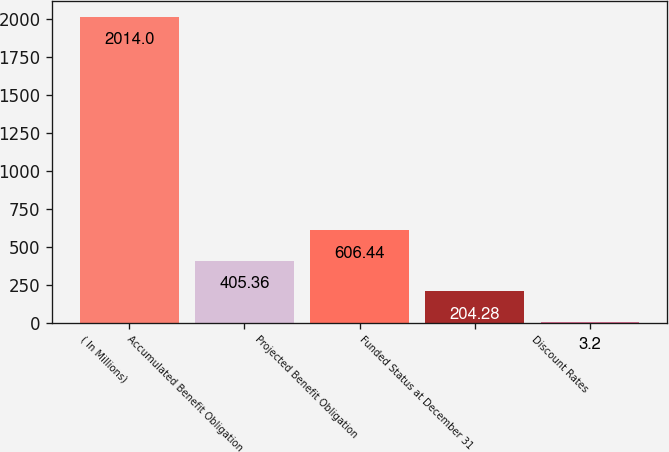Convert chart. <chart><loc_0><loc_0><loc_500><loc_500><bar_chart><fcel>( In Millions)<fcel>Accumulated Benefit Obligation<fcel>Projected Benefit Obligation<fcel>Funded Status at December 31<fcel>Discount Rates<nl><fcel>2014<fcel>405.36<fcel>606.44<fcel>204.28<fcel>3.2<nl></chart> 